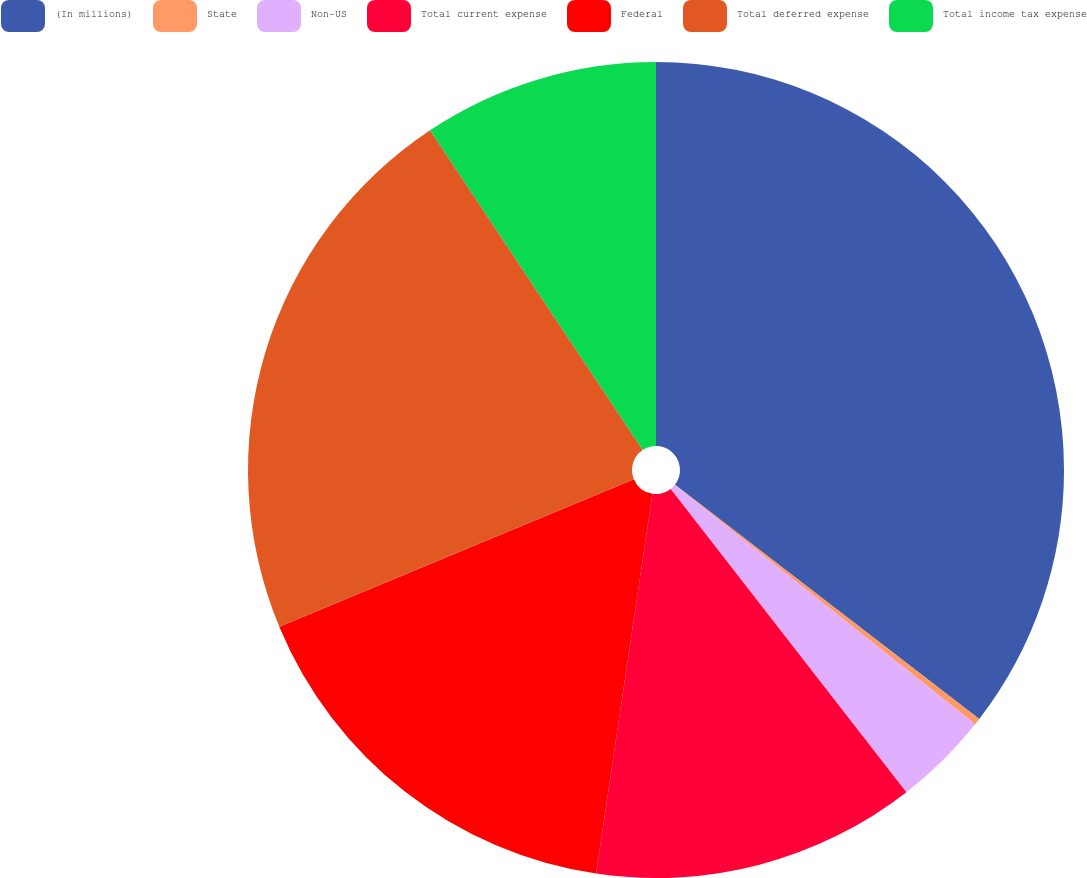Convert chart. <chart><loc_0><loc_0><loc_500><loc_500><pie_chart><fcel>(In millions)<fcel>State<fcel>Non-US<fcel>Total current expense<fcel>Federal<fcel>Total deferred expense<fcel>Total income tax expense<nl><fcel>35.44%<fcel>0.26%<fcel>3.78%<fcel>12.86%<fcel>16.38%<fcel>21.93%<fcel>9.34%<nl></chart> 